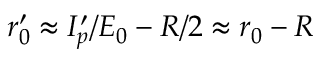Convert formula to latex. <formula><loc_0><loc_0><loc_500><loc_500>r _ { 0 } ^ { \prime } \approx I _ { p } ^ { \prime } / E _ { 0 } - R / 2 \approx r _ { 0 } - R</formula> 